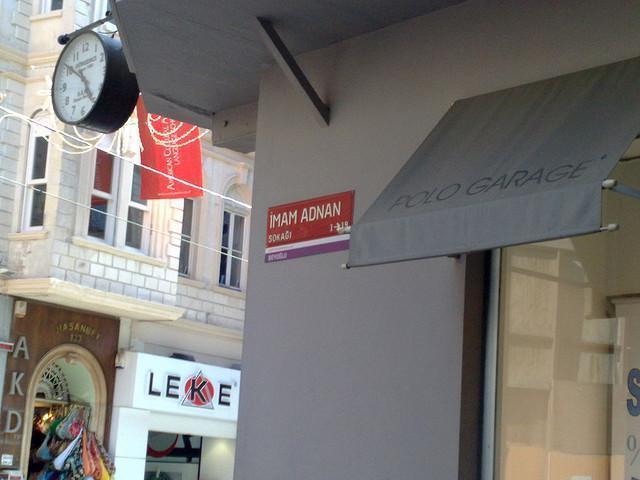What is the name of the Garage?
Select the correct answer and articulate reasoning with the following format: 'Answer: answer
Rationale: rationale.'
Options: Polo, imam, leke, akd. Answer: polo.
Rationale: There is a sign with the name of the garage on it. 